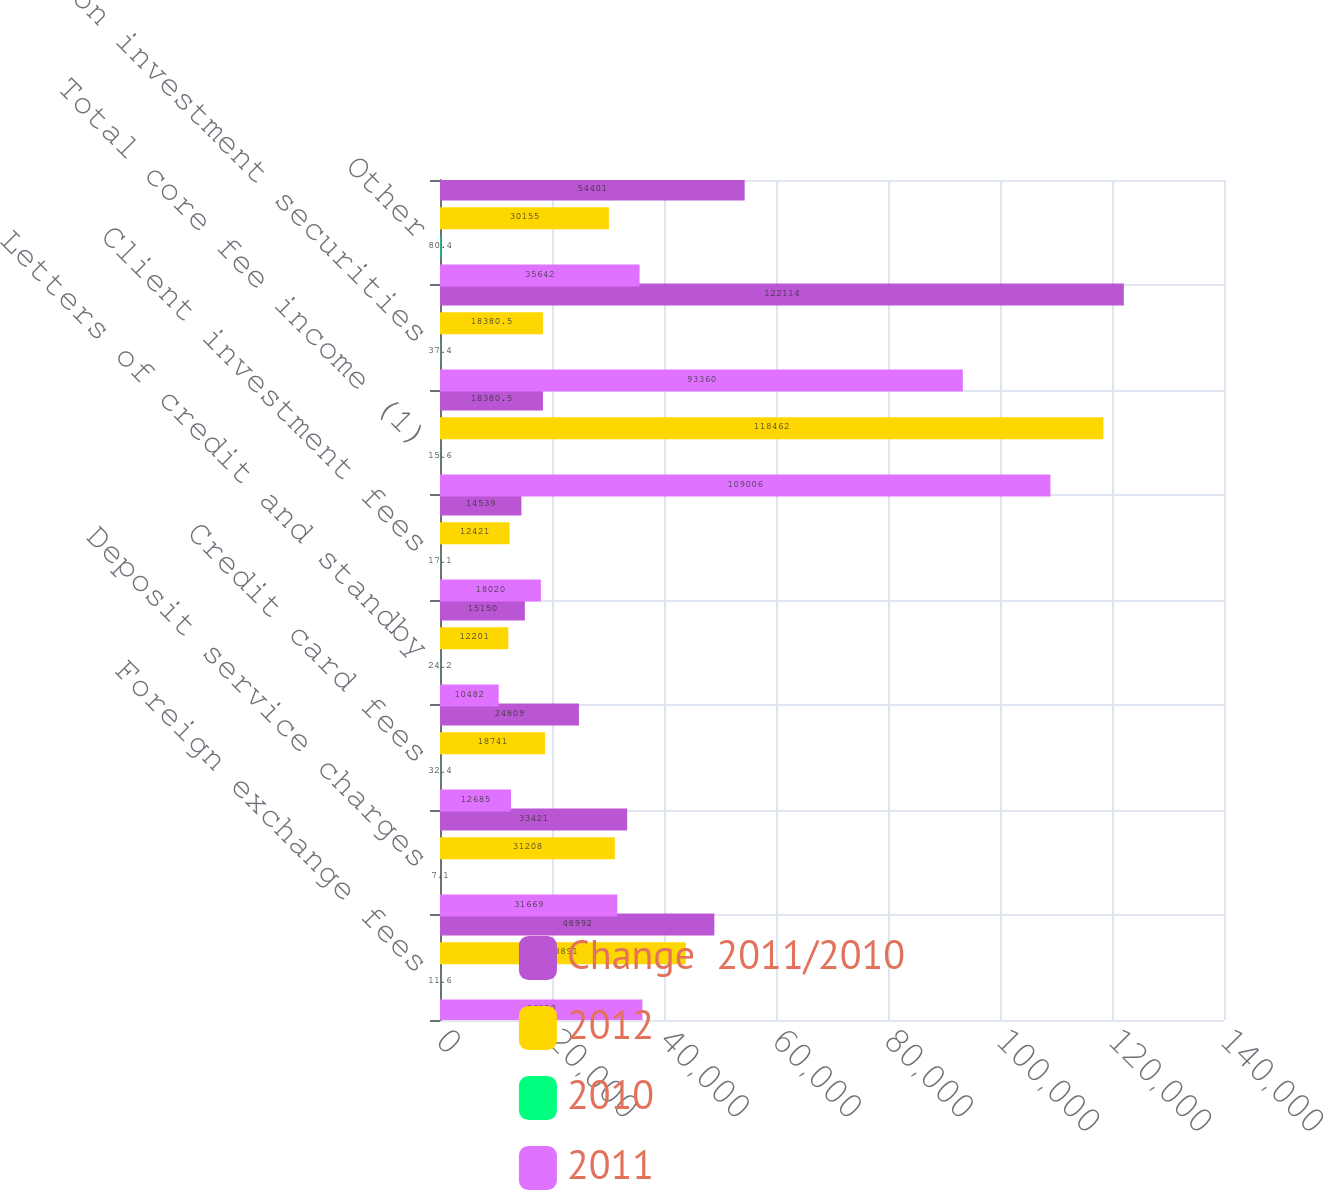Convert chart. <chart><loc_0><loc_0><loc_500><loc_500><stacked_bar_chart><ecel><fcel>Foreign exchange fees<fcel>Deposit service charges<fcel>Credit card fees<fcel>Letters of credit and standby<fcel>Client investment fees<fcel>Total core fee income (1)<fcel>Gains on investment securities<fcel>Other<nl><fcel>Change  2011/2010<fcel>48992<fcel>33421<fcel>24809<fcel>15150<fcel>14539<fcel>18380.5<fcel>122114<fcel>54401<nl><fcel>2012<fcel>43891<fcel>31208<fcel>18741<fcel>12201<fcel>12421<fcel>118462<fcel>18380.5<fcel>30155<nl><fcel>2010<fcel>11.6<fcel>7.1<fcel>32.4<fcel>24.2<fcel>17.1<fcel>15.6<fcel>37.4<fcel>80.4<nl><fcel>2011<fcel>36150<fcel>31669<fcel>12685<fcel>10482<fcel>18020<fcel>109006<fcel>93360<fcel>35642<nl></chart> 